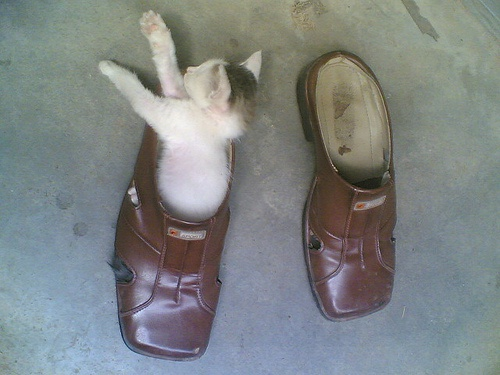Describe the objects in this image and their specific colors. I can see a cat in teal, lightgray, darkgray, and gray tones in this image. 